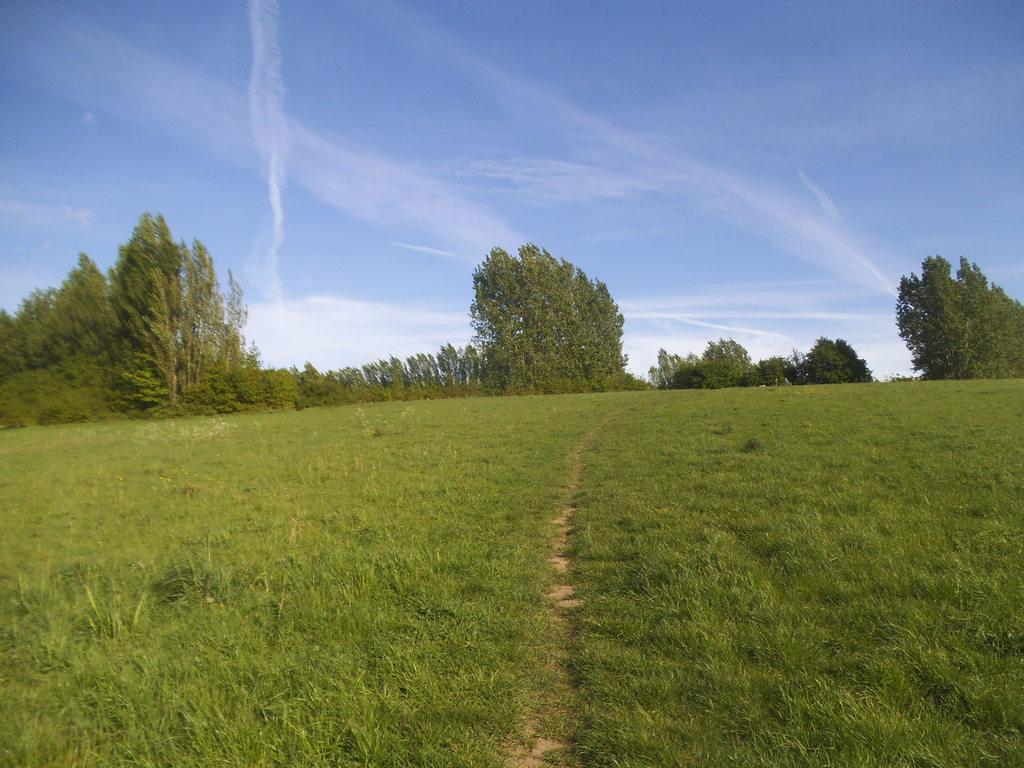What type of ground is visible in the image? The ground with grass is visible in the image. What can be seen in the distance in the image? There are many trees in the background of the image. What else is visible in the background of the image? Clouds are present in the background of the image. What color is the sky in the image? The sky is blue in the image. Can you see any berries growing on the ground in the image? There is no mention of berries in the image, so we cannot determine if any are present. 